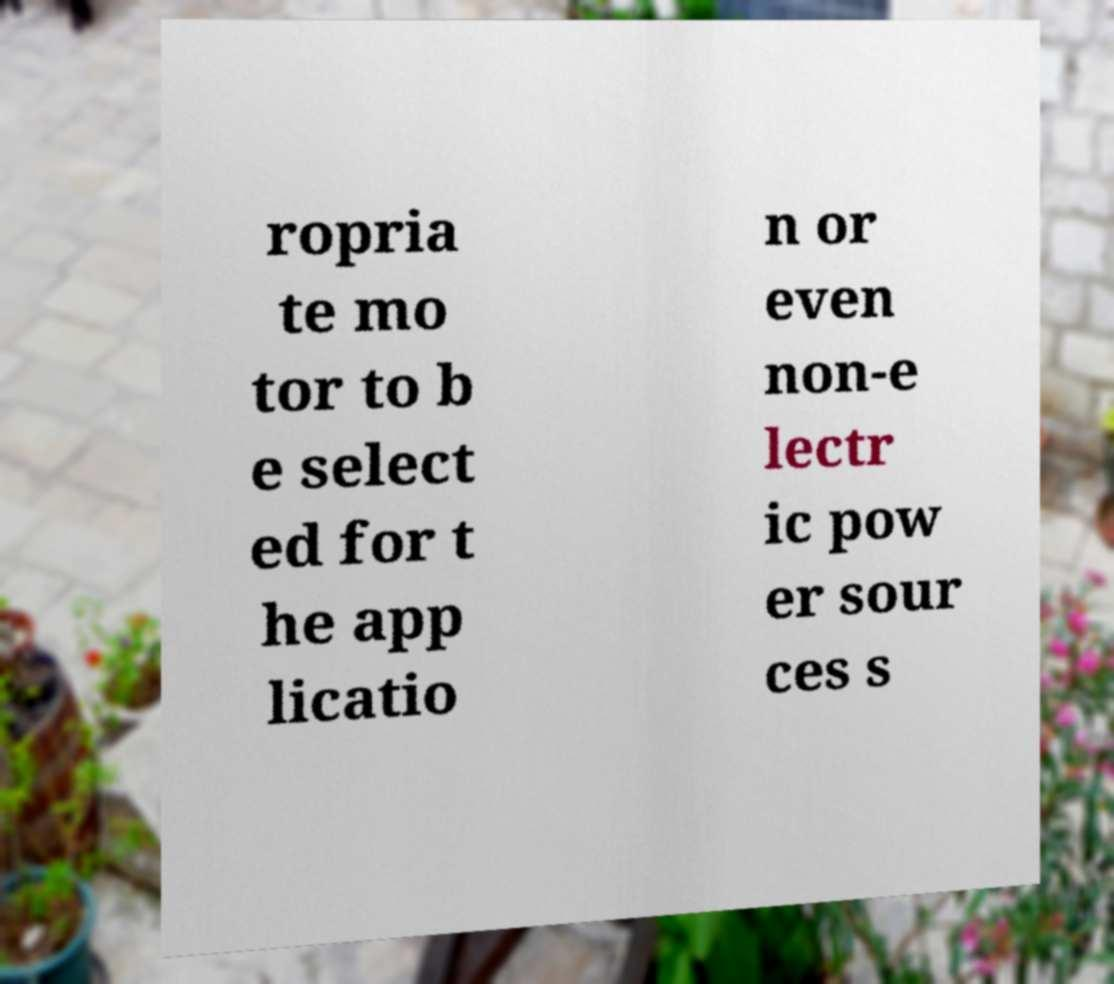Could you assist in decoding the text presented in this image and type it out clearly? ropria te mo tor to b e select ed for t he app licatio n or even non-e lectr ic pow er sour ces s 